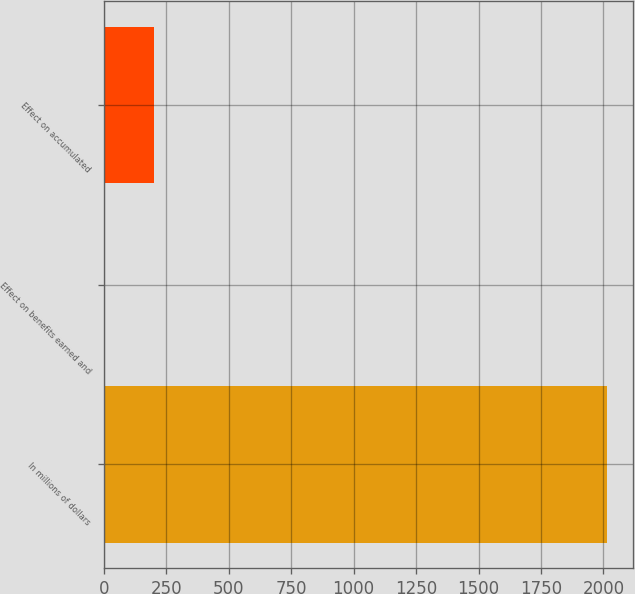Convert chart to OTSL. <chart><loc_0><loc_0><loc_500><loc_500><bar_chart><fcel>In millions of dollars<fcel>Effect on benefits earned and<fcel>Effect on accumulated<nl><fcel>2016<fcel>1<fcel>202.5<nl></chart> 